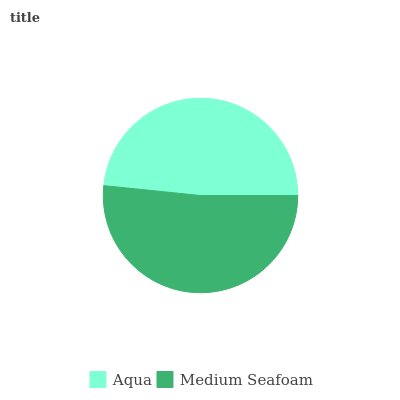Is Aqua the minimum?
Answer yes or no. Yes. Is Medium Seafoam the maximum?
Answer yes or no. Yes. Is Medium Seafoam the minimum?
Answer yes or no. No. Is Medium Seafoam greater than Aqua?
Answer yes or no. Yes. Is Aqua less than Medium Seafoam?
Answer yes or no. Yes. Is Aqua greater than Medium Seafoam?
Answer yes or no. No. Is Medium Seafoam less than Aqua?
Answer yes or no. No. Is Medium Seafoam the high median?
Answer yes or no. Yes. Is Aqua the low median?
Answer yes or no. Yes. Is Aqua the high median?
Answer yes or no. No. Is Medium Seafoam the low median?
Answer yes or no. No. 